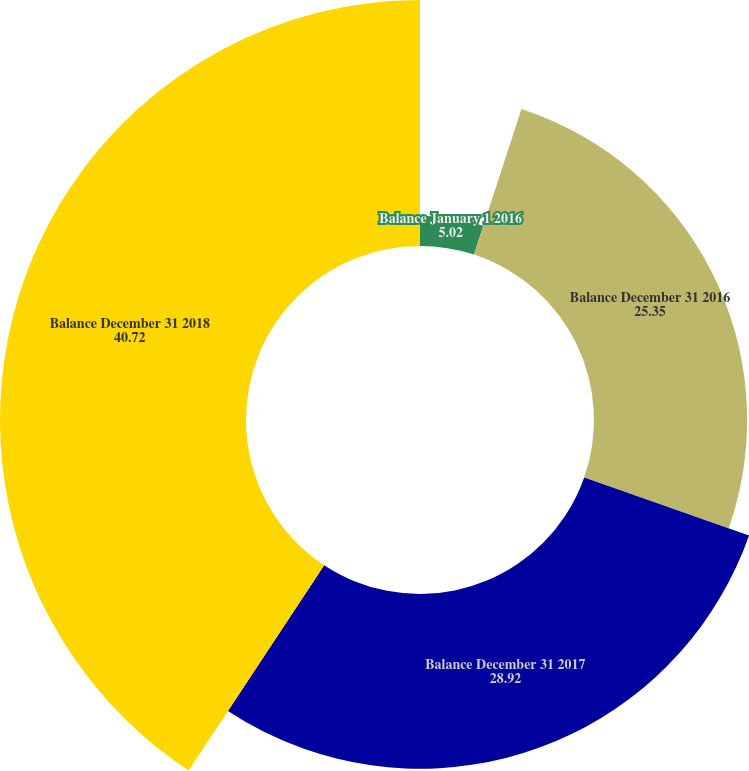Convert chart. <chart><loc_0><loc_0><loc_500><loc_500><pie_chart><fcel>Balance January 1 2016<fcel>Balance December 31 2016<fcel>Balance December 31 2017<fcel>Balance December 31 2018<nl><fcel>5.02%<fcel>25.35%<fcel>28.92%<fcel>40.72%<nl></chart> 